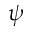<formula> <loc_0><loc_0><loc_500><loc_500>\psi</formula> 